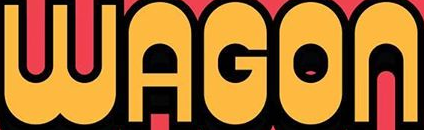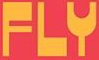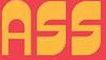What words can you see in these images in sequence, separated by a semicolon? WAGON; FLY; ASS 